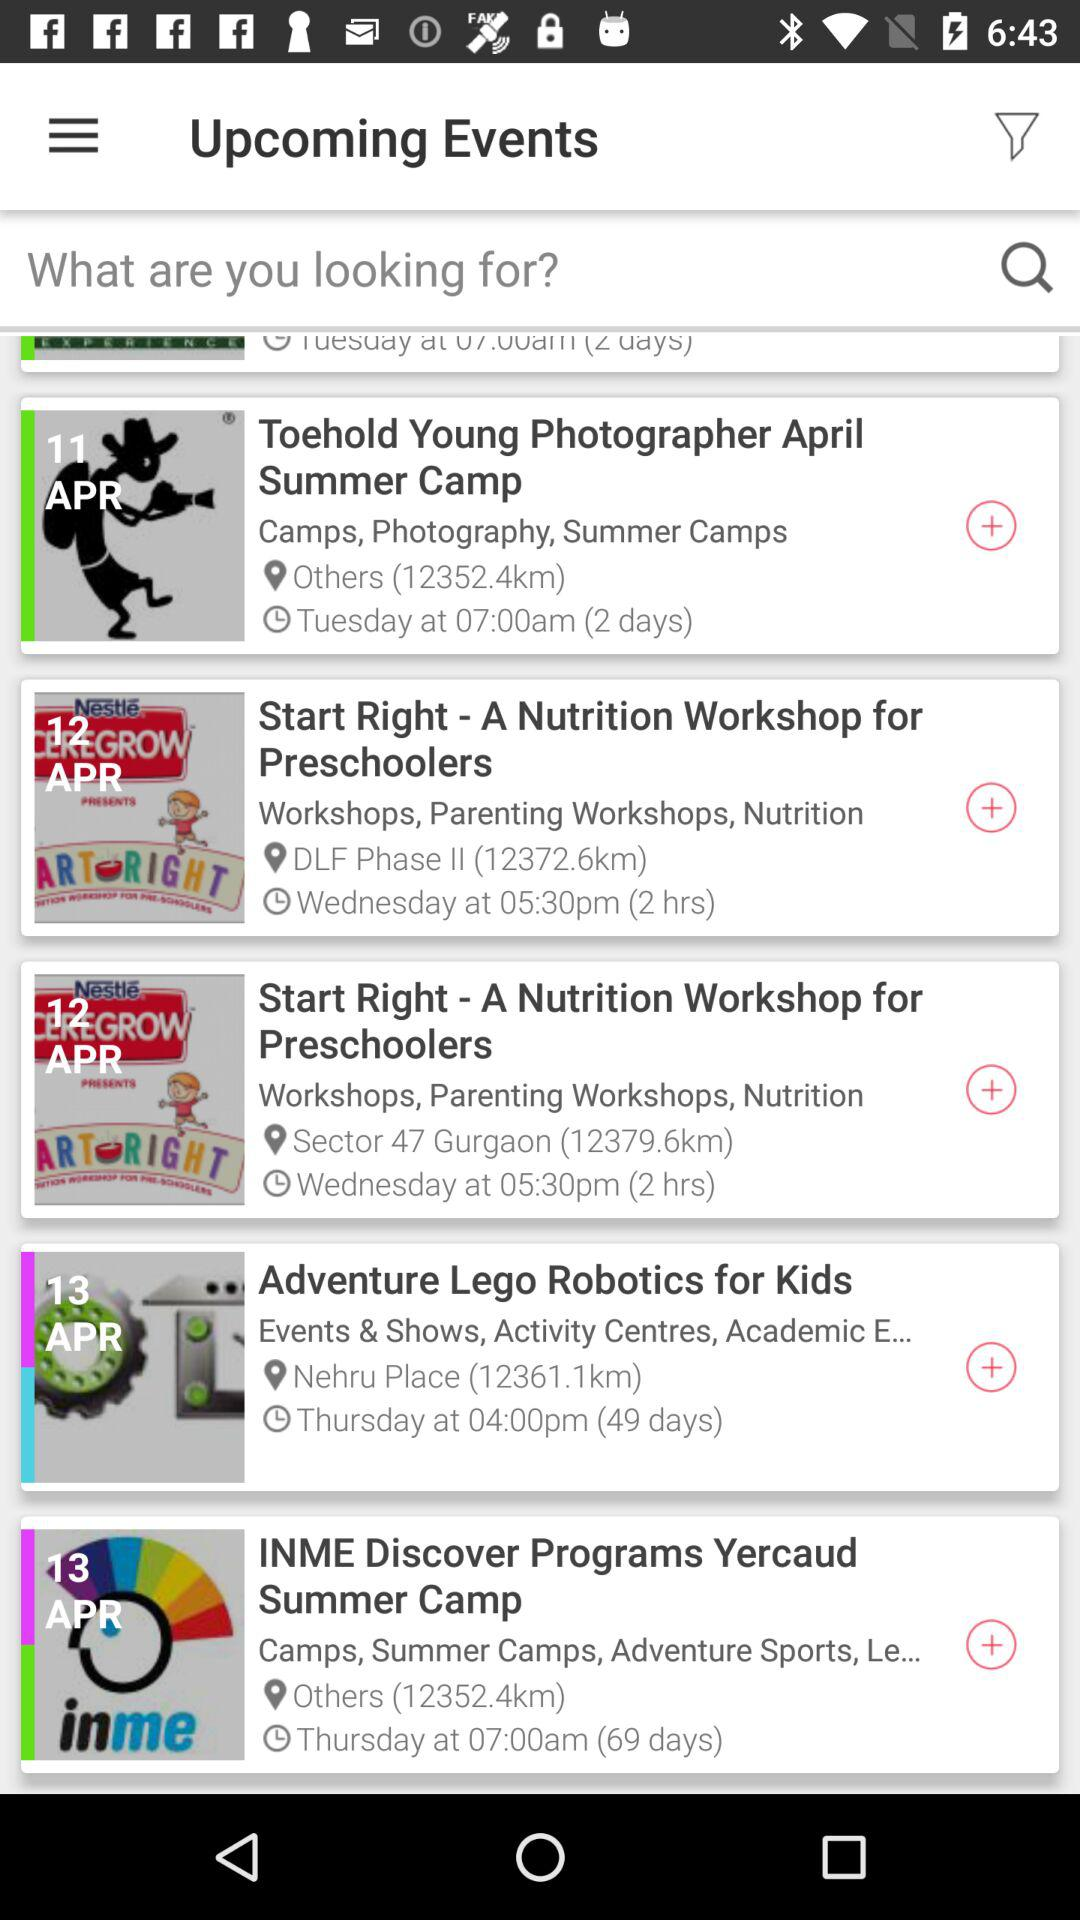What is the address of "Toehold Young Photographer April Summer Camp"? The address is "Others". 